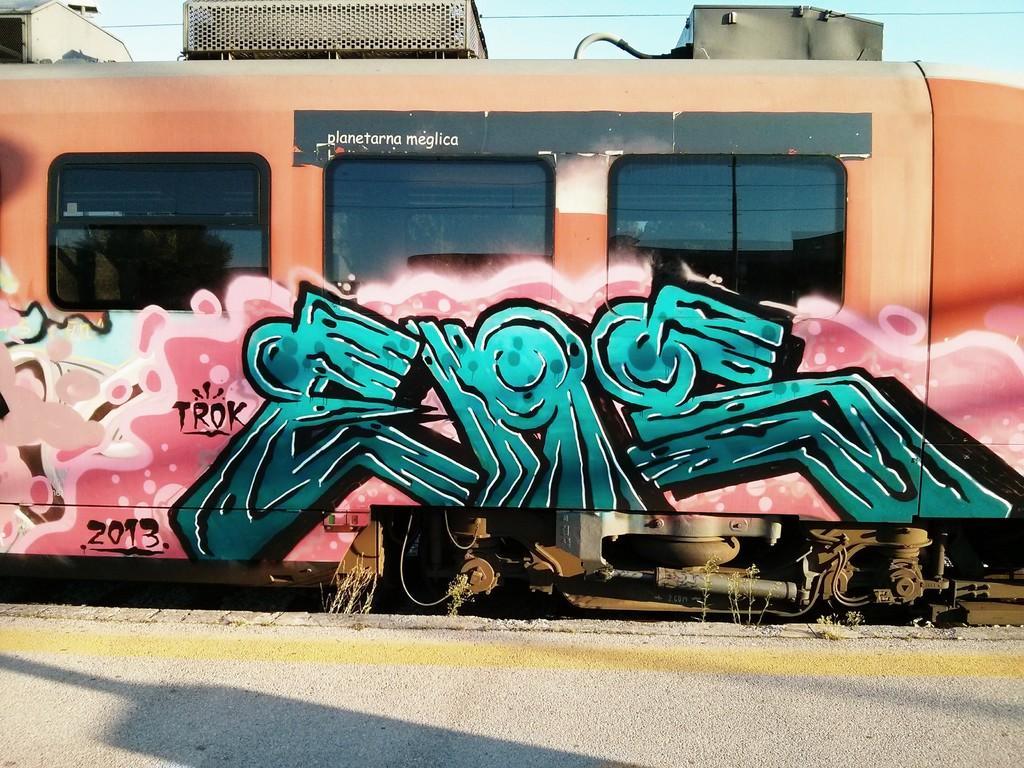Could you give a brief overview of what you see in this image? Graffiti is on the train. These are glass windows. 